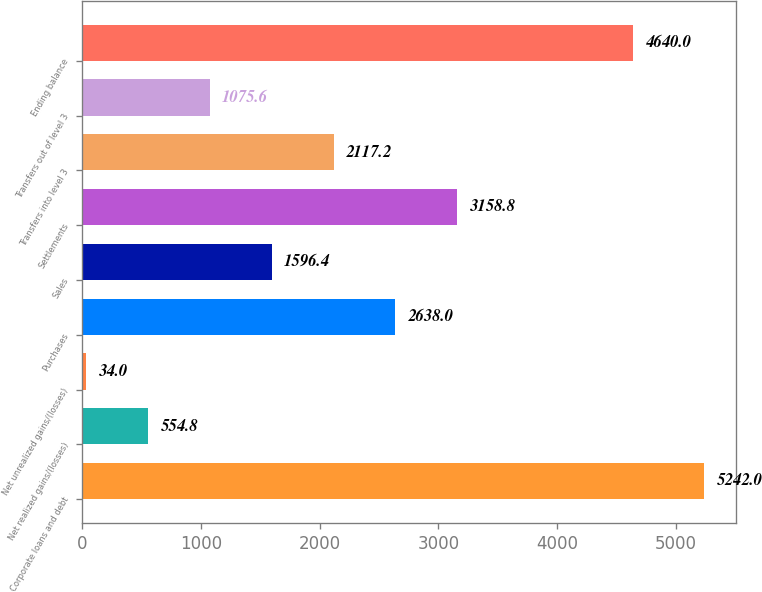Convert chart to OTSL. <chart><loc_0><loc_0><loc_500><loc_500><bar_chart><fcel>Corporate loans and debt<fcel>Net realized gains/(losses)<fcel>Net unrealized gains/(losses)<fcel>Purchases<fcel>Sales<fcel>Settlements<fcel>Transfers into level 3<fcel>Transfers out of level 3<fcel>Ending balance<nl><fcel>5242<fcel>554.8<fcel>34<fcel>2638<fcel>1596.4<fcel>3158.8<fcel>2117.2<fcel>1075.6<fcel>4640<nl></chart> 